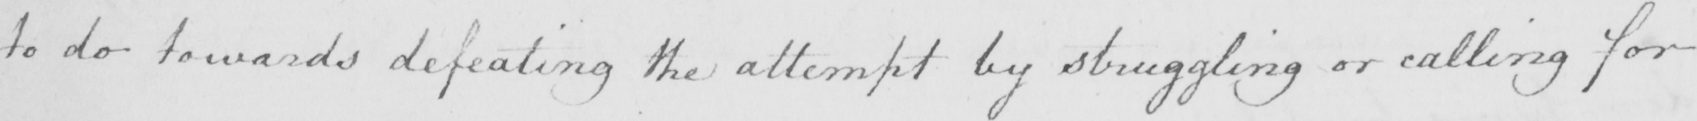What text is written in this handwritten line? to do towards defeating the attempt by struggling or calling for 